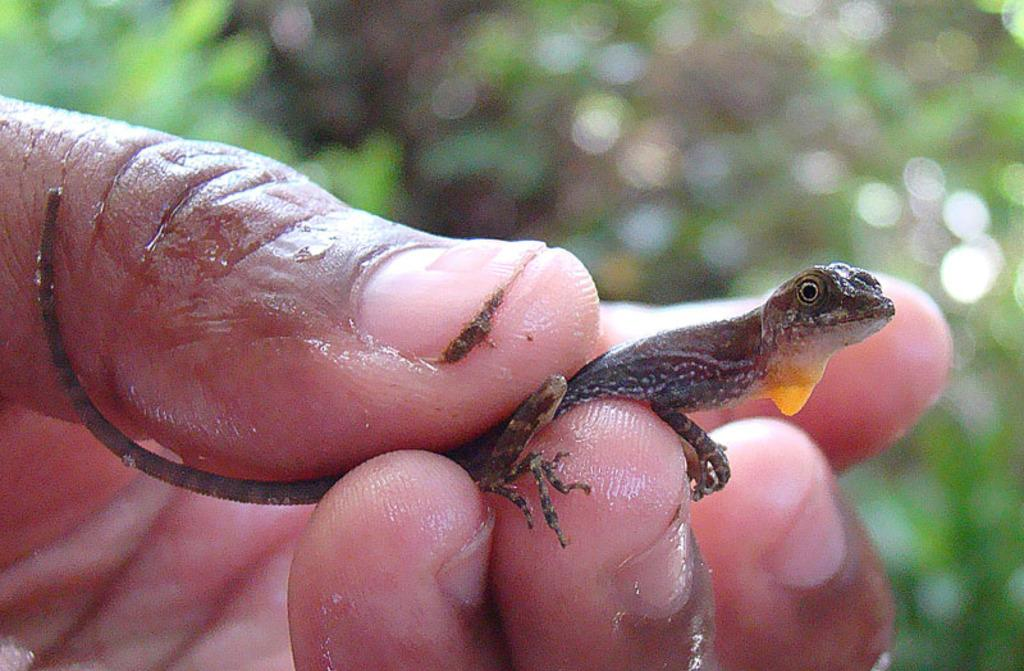What part of a person can be seen in the image? There is a person's hand in the image. What type of living creature is also present in the image? There is an animal in the image. Can you describe the background of the image? The background of the image is blurred. What type of box is being loaded onto the truck in the image? There is no box or truck present in the image. What suggestion is being made by the person in the image? There is no suggestion being made in the image, as it only shows a person's hand and an animal. 